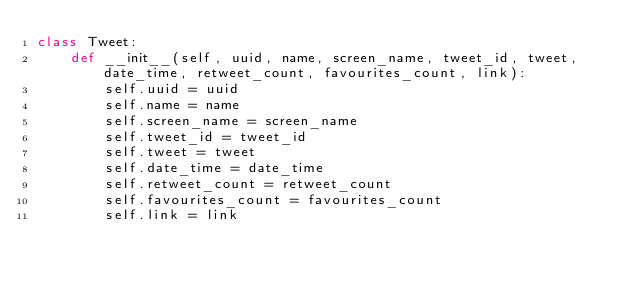<code> <loc_0><loc_0><loc_500><loc_500><_Python_>class Tweet:
    def __init__(self, uuid, name, screen_name, tweet_id, tweet, date_time, retweet_count, favourites_count, link):
        self.uuid = uuid
        self.name = name
        self.screen_name = screen_name
        self.tweet_id = tweet_id
        self.tweet = tweet
        self.date_time = date_time
        self.retweet_count = retweet_count
        self.favourites_count = favourites_count
        self.link = link
</code> 